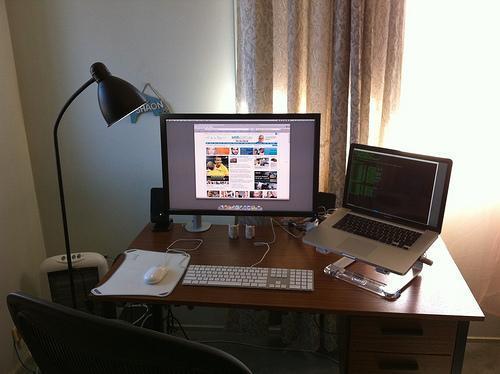How many computers are on the desk?
Give a very brief answer. 2. 